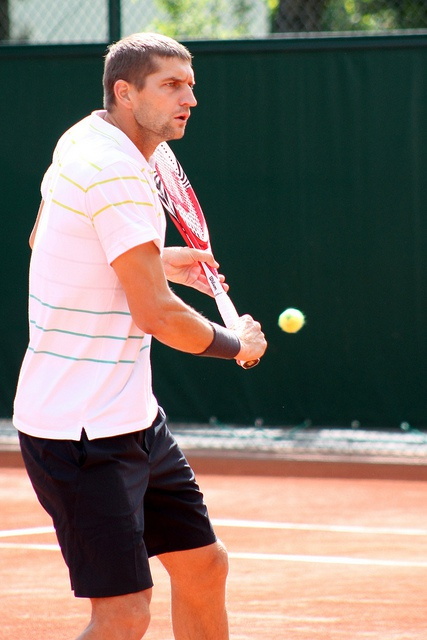Describe the objects in this image and their specific colors. I can see people in black, lavender, salmon, and red tones, tennis racket in black, white, lightpink, salmon, and red tones, and sports ball in black, gold, ivory, khaki, and lightgreen tones in this image. 